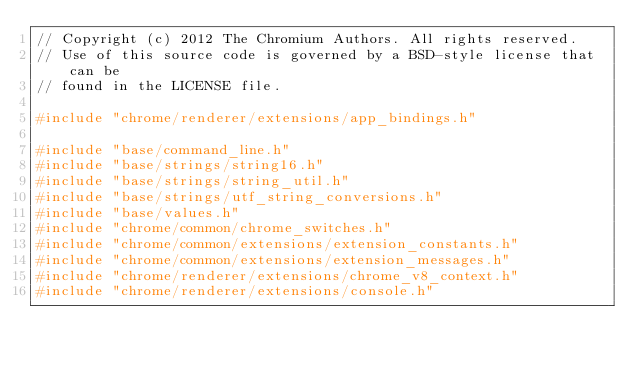<code> <loc_0><loc_0><loc_500><loc_500><_C++_>// Copyright (c) 2012 The Chromium Authors. All rights reserved.
// Use of this source code is governed by a BSD-style license that can be
// found in the LICENSE file.

#include "chrome/renderer/extensions/app_bindings.h"

#include "base/command_line.h"
#include "base/strings/string16.h"
#include "base/strings/string_util.h"
#include "base/strings/utf_string_conversions.h"
#include "base/values.h"
#include "chrome/common/chrome_switches.h"
#include "chrome/common/extensions/extension_constants.h"
#include "chrome/common/extensions/extension_messages.h"
#include "chrome/renderer/extensions/chrome_v8_context.h"
#include "chrome/renderer/extensions/console.h"</code> 